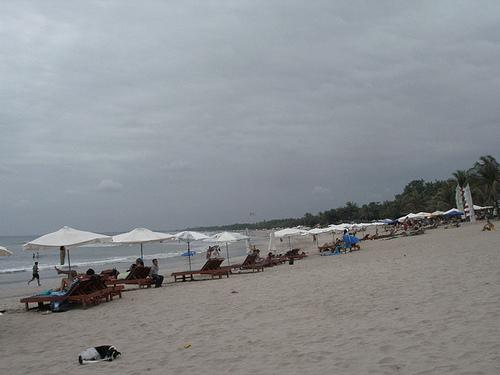What body of water is this?
Quick response, please. Ocean. Is it sunny?
Give a very brief answer. No. Are these people planning to go on a boat ride?
Quick response, please. No. How many chairs are on the beach?
Be succinct. 6. Are there people on the chairs?
Keep it brief. Yes. How many umbrellas are there?
Quick response, please. 20. How many birds are in the closest spot?
Short answer required. 0. Is it warm there?
Quick response, please. Yes. What are the umbrella hoods made of?
Concise answer only. Fabric. How many toilets are there?
Write a very short answer. 0. How many people in this photo?
Give a very brief answer. Many. Is there sand on the ground?
Quick response, please. Yes. How many umbrellas are in this photo?
Be succinct. 18. Are all the umbrellas the same color?
Concise answer only. Yes. Is it going to rain?
Keep it brief. Yes. Is this a sunset?
Keep it brief. No. Is this picture uphill or downhill?
Be succinct. Downhill. How many birds are standing in this field?
Concise answer only. 0. Is it a cloudy day?
Answer briefly. Yes. Are there boats on the water?
Keep it brief. No. Is it a sunny day?
Quick response, please. No. Are the umbrellas open?
Quick response, please. Yes. What is the man sitting on?
Concise answer only. Beach chair. Where are the plaid shorts?
Write a very short answer. Nowhere. Is the season likely summer?
Be succinct. Yes. What is the person on the left wearing?
Short answer required. Swimsuit. Is it probably cold here?
Short answer required. No. Is anyone sitting in the chairs?
Write a very short answer. Yes. What type of day is it?
Quick response, please. Cloudy. What is this place called?
Concise answer only. Beach. What are the objects in the air?
Answer briefly. Clouds. Does this look like a busy beach?
Quick response, please. Yes. What color are the umbrellas?
Quick response, please. White. 